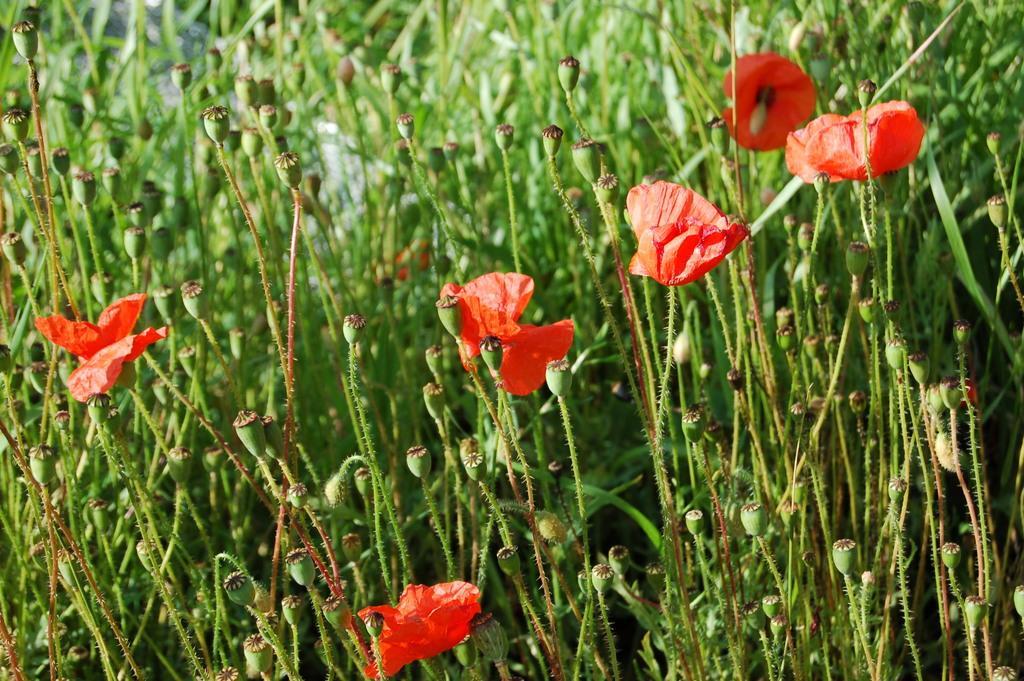How would you summarize this image in a sentence or two? In this picture, we see the plants which have flowers and the buds. The buds are in green color and the flowers are in red color. This picture is blurred in the background. 